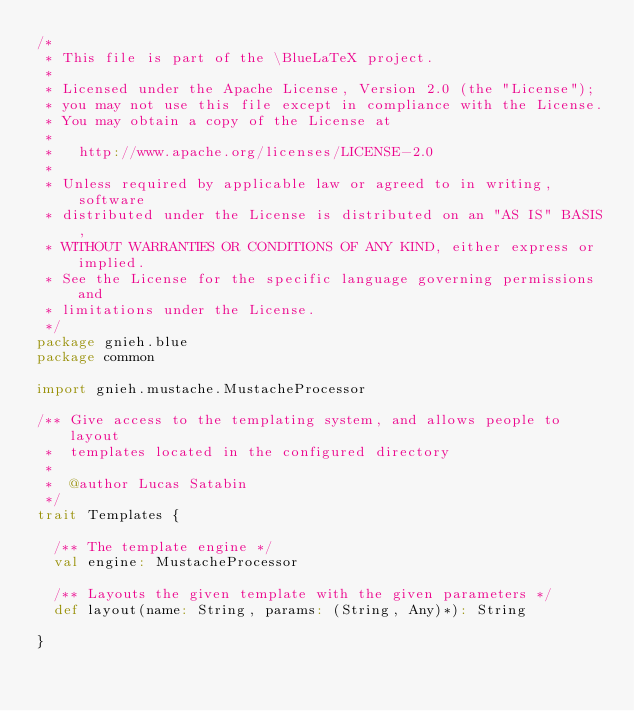Convert code to text. <code><loc_0><loc_0><loc_500><loc_500><_Scala_>/*
 * This file is part of the \BlueLaTeX project.
 *
 * Licensed under the Apache License, Version 2.0 (the "License");
 * you may not use this file except in compliance with the License.
 * You may obtain a copy of the License at
 *
 *   http://www.apache.org/licenses/LICENSE-2.0
 *
 * Unless required by applicable law or agreed to in writing, software
 * distributed under the License is distributed on an "AS IS" BASIS,
 * WITHOUT WARRANTIES OR CONDITIONS OF ANY KIND, either express or implied.
 * See the License for the specific language governing permissions and
 * limitations under the License.
 */
package gnieh.blue
package common

import gnieh.mustache.MustacheProcessor

/** Give access to the templating system, and allows people to layout
 *  templates located in the configured directory
 *
 *  @author Lucas Satabin
 */
trait Templates {

  /** The template engine */
  val engine: MustacheProcessor

  /** Layouts the given template with the given parameters */
  def layout(name: String, params: (String, Any)*): String

}
</code> 